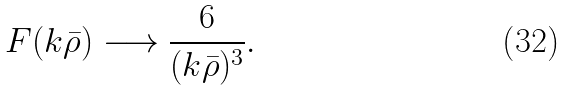Convert formula to latex. <formula><loc_0><loc_0><loc_500><loc_500>F ( k \bar { \rho } ) \longrightarrow \frac { 6 } { ( k \bar { \rho } ) ^ { 3 } } .</formula> 